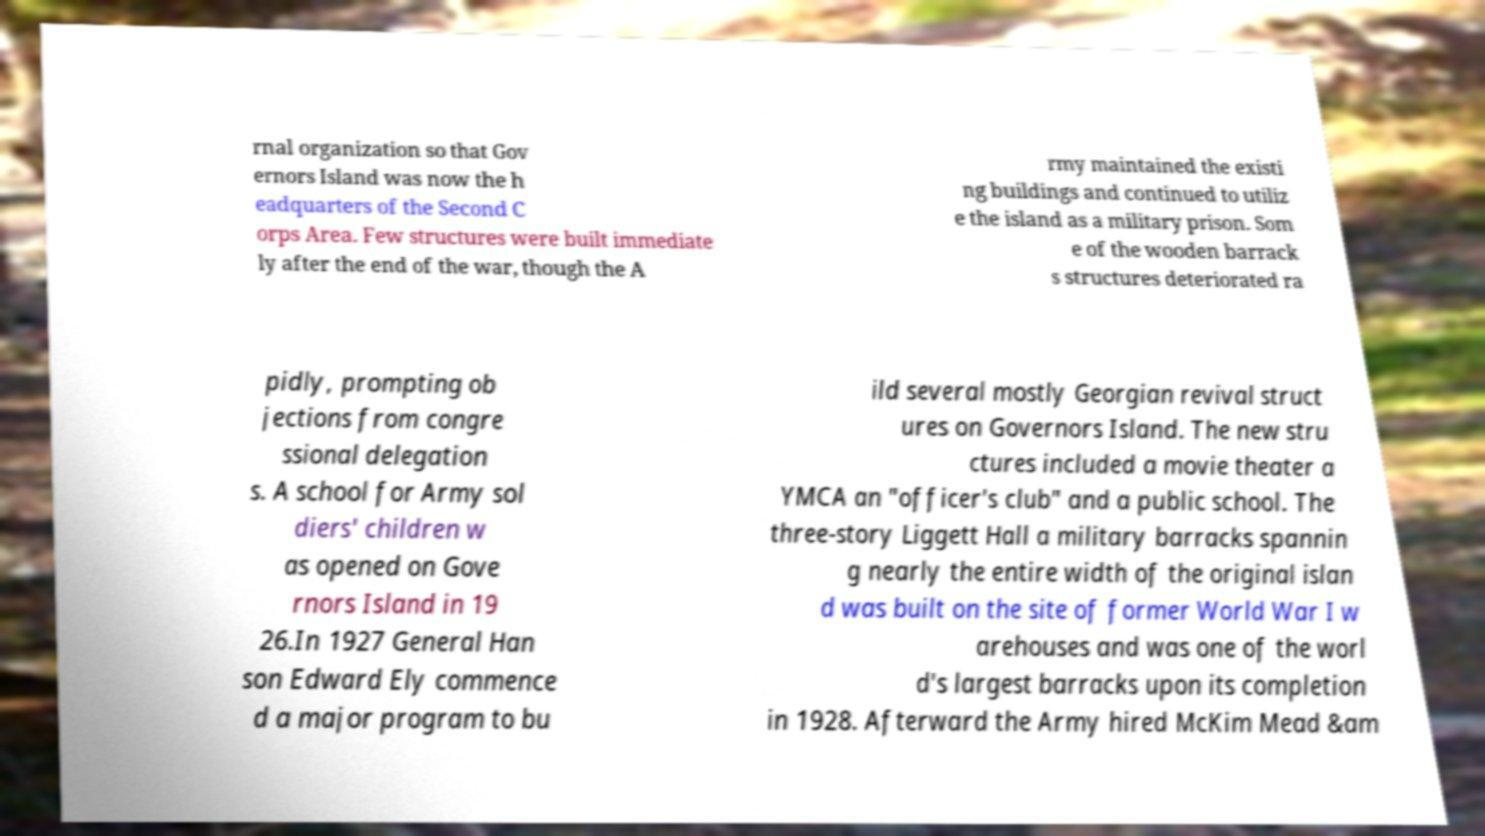Can you accurately transcribe the text from the provided image for me? rnal organization so that Gov ernors Island was now the h eadquarters of the Second C orps Area. Few structures were built immediate ly after the end of the war, though the A rmy maintained the existi ng buildings and continued to utiliz e the island as a military prison. Som e of the wooden barrack s structures deteriorated ra pidly, prompting ob jections from congre ssional delegation s. A school for Army sol diers' children w as opened on Gove rnors Island in 19 26.In 1927 General Han son Edward Ely commence d a major program to bu ild several mostly Georgian revival struct ures on Governors Island. The new stru ctures included a movie theater a YMCA an "officer's club" and a public school. The three-story Liggett Hall a military barracks spannin g nearly the entire width of the original islan d was built on the site of former World War I w arehouses and was one of the worl d's largest barracks upon its completion in 1928. Afterward the Army hired McKim Mead &am 